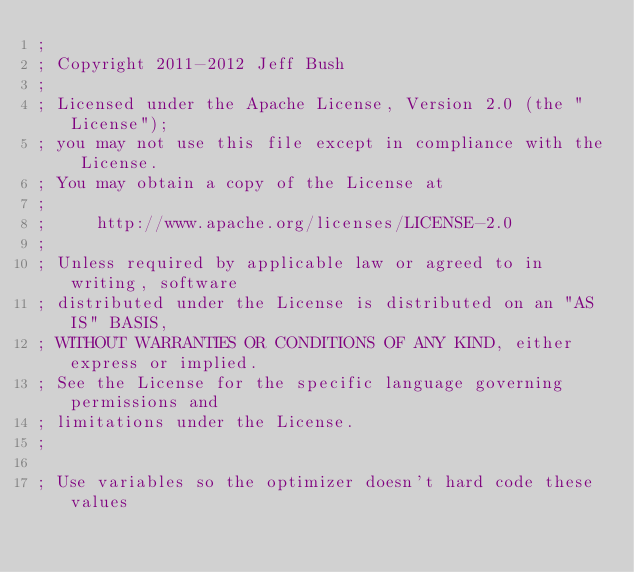Convert code to text. <code><loc_0><loc_0><loc_500><loc_500><_Lisp_>;
; Copyright 2011-2012 Jeff Bush
;
; Licensed under the Apache License, Version 2.0 (the "License");
; you may not use this file except in compliance with the License.
; You may obtain a copy of the License at
;
;     http://www.apache.org/licenses/LICENSE-2.0
;
; Unless required by applicable law or agreed to in writing, software
; distributed under the License is distributed on an "AS IS" BASIS,
; WITHOUT WARRANTIES OR CONDITIONS OF ANY KIND, either express or implied.
; See the License for the specific language governing permissions and
; limitations under the License.
;

; Use variables so the optimizer doesn't hard code these values</code> 